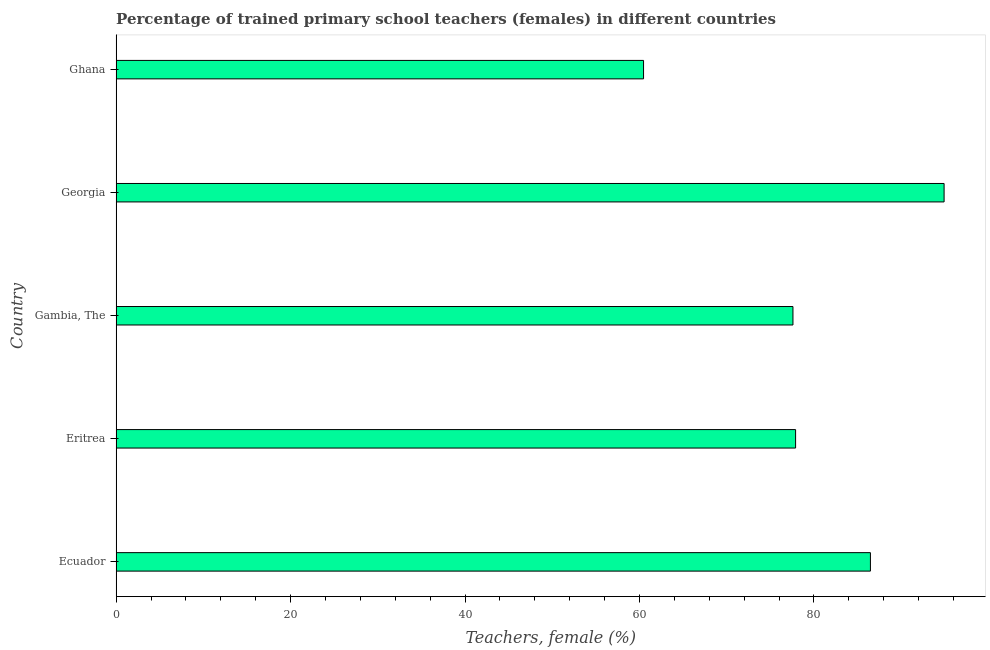Does the graph contain any zero values?
Ensure brevity in your answer.  No. Does the graph contain grids?
Your response must be concise. No. What is the title of the graph?
Make the answer very short. Percentage of trained primary school teachers (females) in different countries. What is the label or title of the X-axis?
Offer a terse response. Teachers, female (%). What is the label or title of the Y-axis?
Make the answer very short. Country. What is the percentage of trained female teachers in Gambia, The?
Provide a short and direct response. 77.59. Across all countries, what is the maximum percentage of trained female teachers?
Provide a succinct answer. 94.92. Across all countries, what is the minimum percentage of trained female teachers?
Offer a terse response. 60.46. In which country was the percentage of trained female teachers maximum?
Ensure brevity in your answer.  Georgia. What is the sum of the percentage of trained female teachers?
Offer a very short reply. 397.33. What is the difference between the percentage of trained female teachers in Gambia, The and Georgia?
Ensure brevity in your answer.  -17.33. What is the average percentage of trained female teachers per country?
Provide a short and direct response. 79.47. What is the median percentage of trained female teachers?
Provide a short and direct response. 77.89. In how many countries, is the percentage of trained female teachers greater than 80 %?
Ensure brevity in your answer.  2. What is the ratio of the percentage of trained female teachers in Ecuador to that in Gambia, The?
Ensure brevity in your answer.  1.11. What is the difference between the highest and the second highest percentage of trained female teachers?
Offer a very short reply. 8.45. Is the sum of the percentage of trained female teachers in Gambia, The and Georgia greater than the maximum percentage of trained female teachers across all countries?
Ensure brevity in your answer.  Yes. What is the difference between the highest and the lowest percentage of trained female teachers?
Offer a very short reply. 34.45. How many bars are there?
Provide a succinct answer. 5. Are all the bars in the graph horizontal?
Give a very brief answer. Yes. What is the difference between two consecutive major ticks on the X-axis?
Your answer should be compact. 20. What is the Teachers, female (%) in Ecuador?
Offer a terse response. 86.47. What is the Teachers, female (%) in Eritrea?
Ensure brevity in your answer.  77.89. What is the Teachers, female (%) in Gambia, The?
Offer a very short reply. 77.59. What is the Teachers, female (%) in Georgia?
Keep it short and to the point. 94.92. What is the Teachers, female (%) of Ghana?
Keep it short and to the point. 60.46. What is the difference between the Teachers, female (%) in Ecuador and Eritrea?
Your response must be concise. 8.58. What is the difference between the Teachers, female (%) in Ecuador and Gambia, The?
Your answer should be very brief. 8.88. What is the difference between the Teachers, female (%) in Ecuador and Georgia?
Ensure brevity in your answer.  -8.44. What is the difference between the Teachers, female (%) in Ecuador and Ghana?
Give a very brief answer. 26.01. What is the difference between the Teachers, female (%) in Eritrea and Gambia, The?
Provide a short and direct response. 0.3. What is the difference between the Teachers, female (%) in Eritrea and Georgia?
Give a very brief answer. -17.02. What is the difference between the Teachers, female (%) in Eritrea and Ghana?
Offer a terse response. 17.43. What is the difference between the Teachers, female (%) in Gambia, The and Georgia?
Provide a short and direct response. -17.33. What is the difference between the Teachers, female (%) in Gambia, The and Ghana?
Ensure brevity in your answer.  17.13. What is the difference between the Teachers, female (%) in Georgia and Ghana?
Your answer should be compact. 34.45. What is the ratio of the Teachers, female (%) in Ecuador to that in Eritrea?
Make the answer very short. 1.11. What is the ratio of the Teachers, female (%) in Ecuador to that in Gambia, The?
Make the answer very short. 1.11. What is the ratio of the Teachers, female (%) in Ecuador to that in Georgia?
Your answer should be very brief. 0.91. What is the ratio of the Teachers, female (%) in Ecuador to that in Ghana?
Offer a very short reply. 1.43. What is the ratio of the Teachers, female (%) in Eritrea to that in Gambia, The?
Offer a very short reply. 1. What is the ratio of the Teachers, female (%) in Eritrea to that in Georgia?
Your answer should be compact. 0.82. What is the ratio of the Teachers, female (%) in Eritrea to that in Ghana?
Keep it short and to the point. 1.29. What is the ratio of the Teachers, female (%) in Gambia, The to that in Georgia?
Provide a short and direct response. 0.82. What is the ratio of the Teachers, female (%) in Gambia, The to that in Ghana?
Offer a terse response. 1.28. What is the ratio of the Teachers, female (%) in Georgia to that in Ghana?
Offer a terse response. 1.57. 